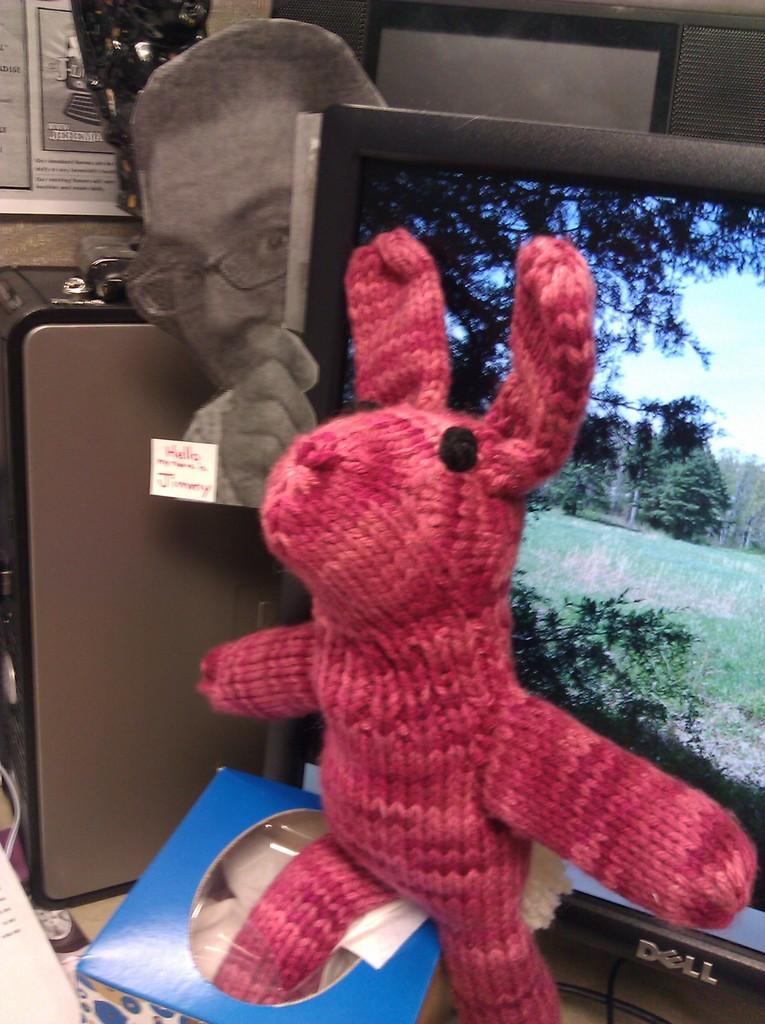In one or two sentences, can you explain what this image depicts? In this picture we can see a toy, monitor, CPU and a board. Behind the CPU, there are some objects. At the bottom left corner of the image, there is a paper. 